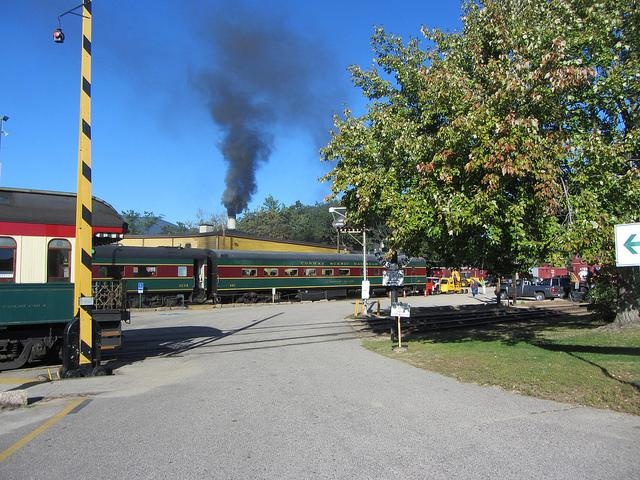In which direction is the train going that is behind the raised arm?

Choices:
A) forwards
B) backwards
C) nowhere
D) not train nowhere 